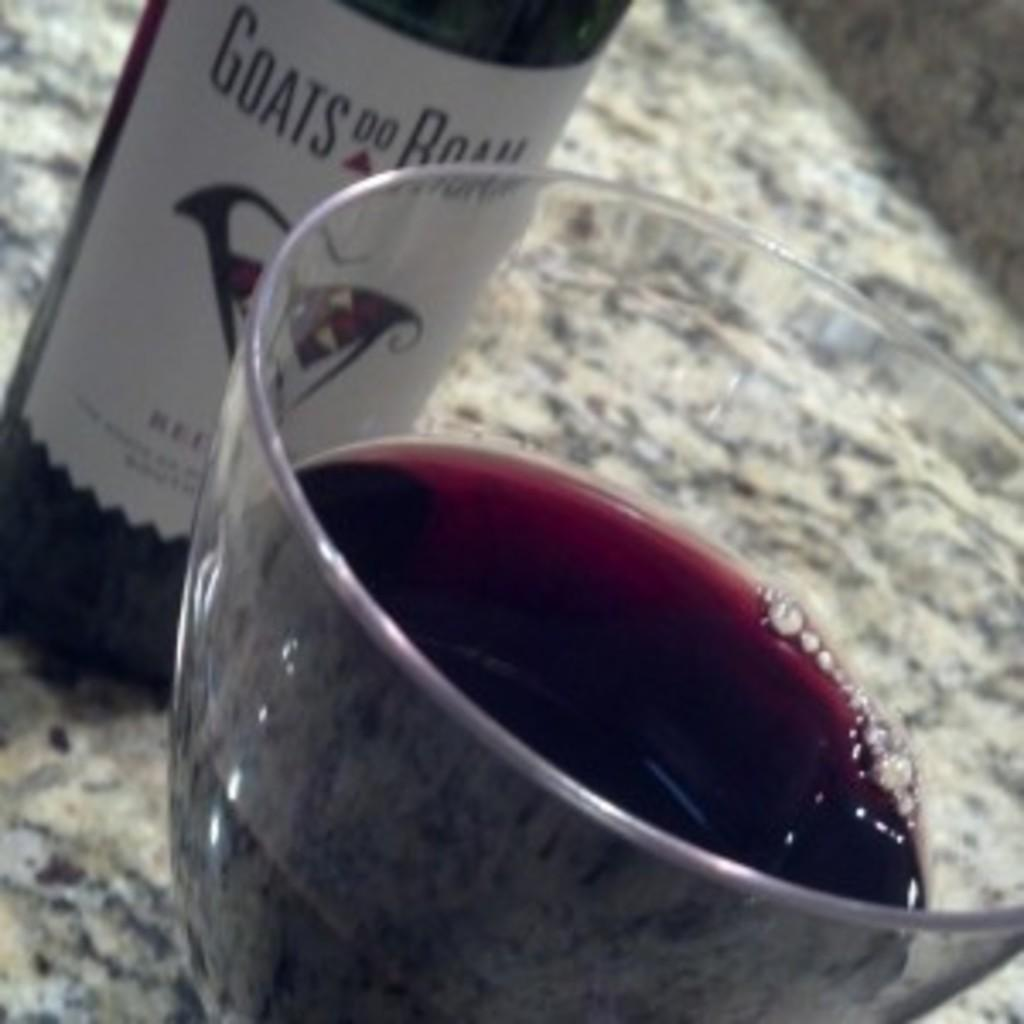Provide a one-sentence caption for the provided image. A wine bottle called goats do roam in red. 